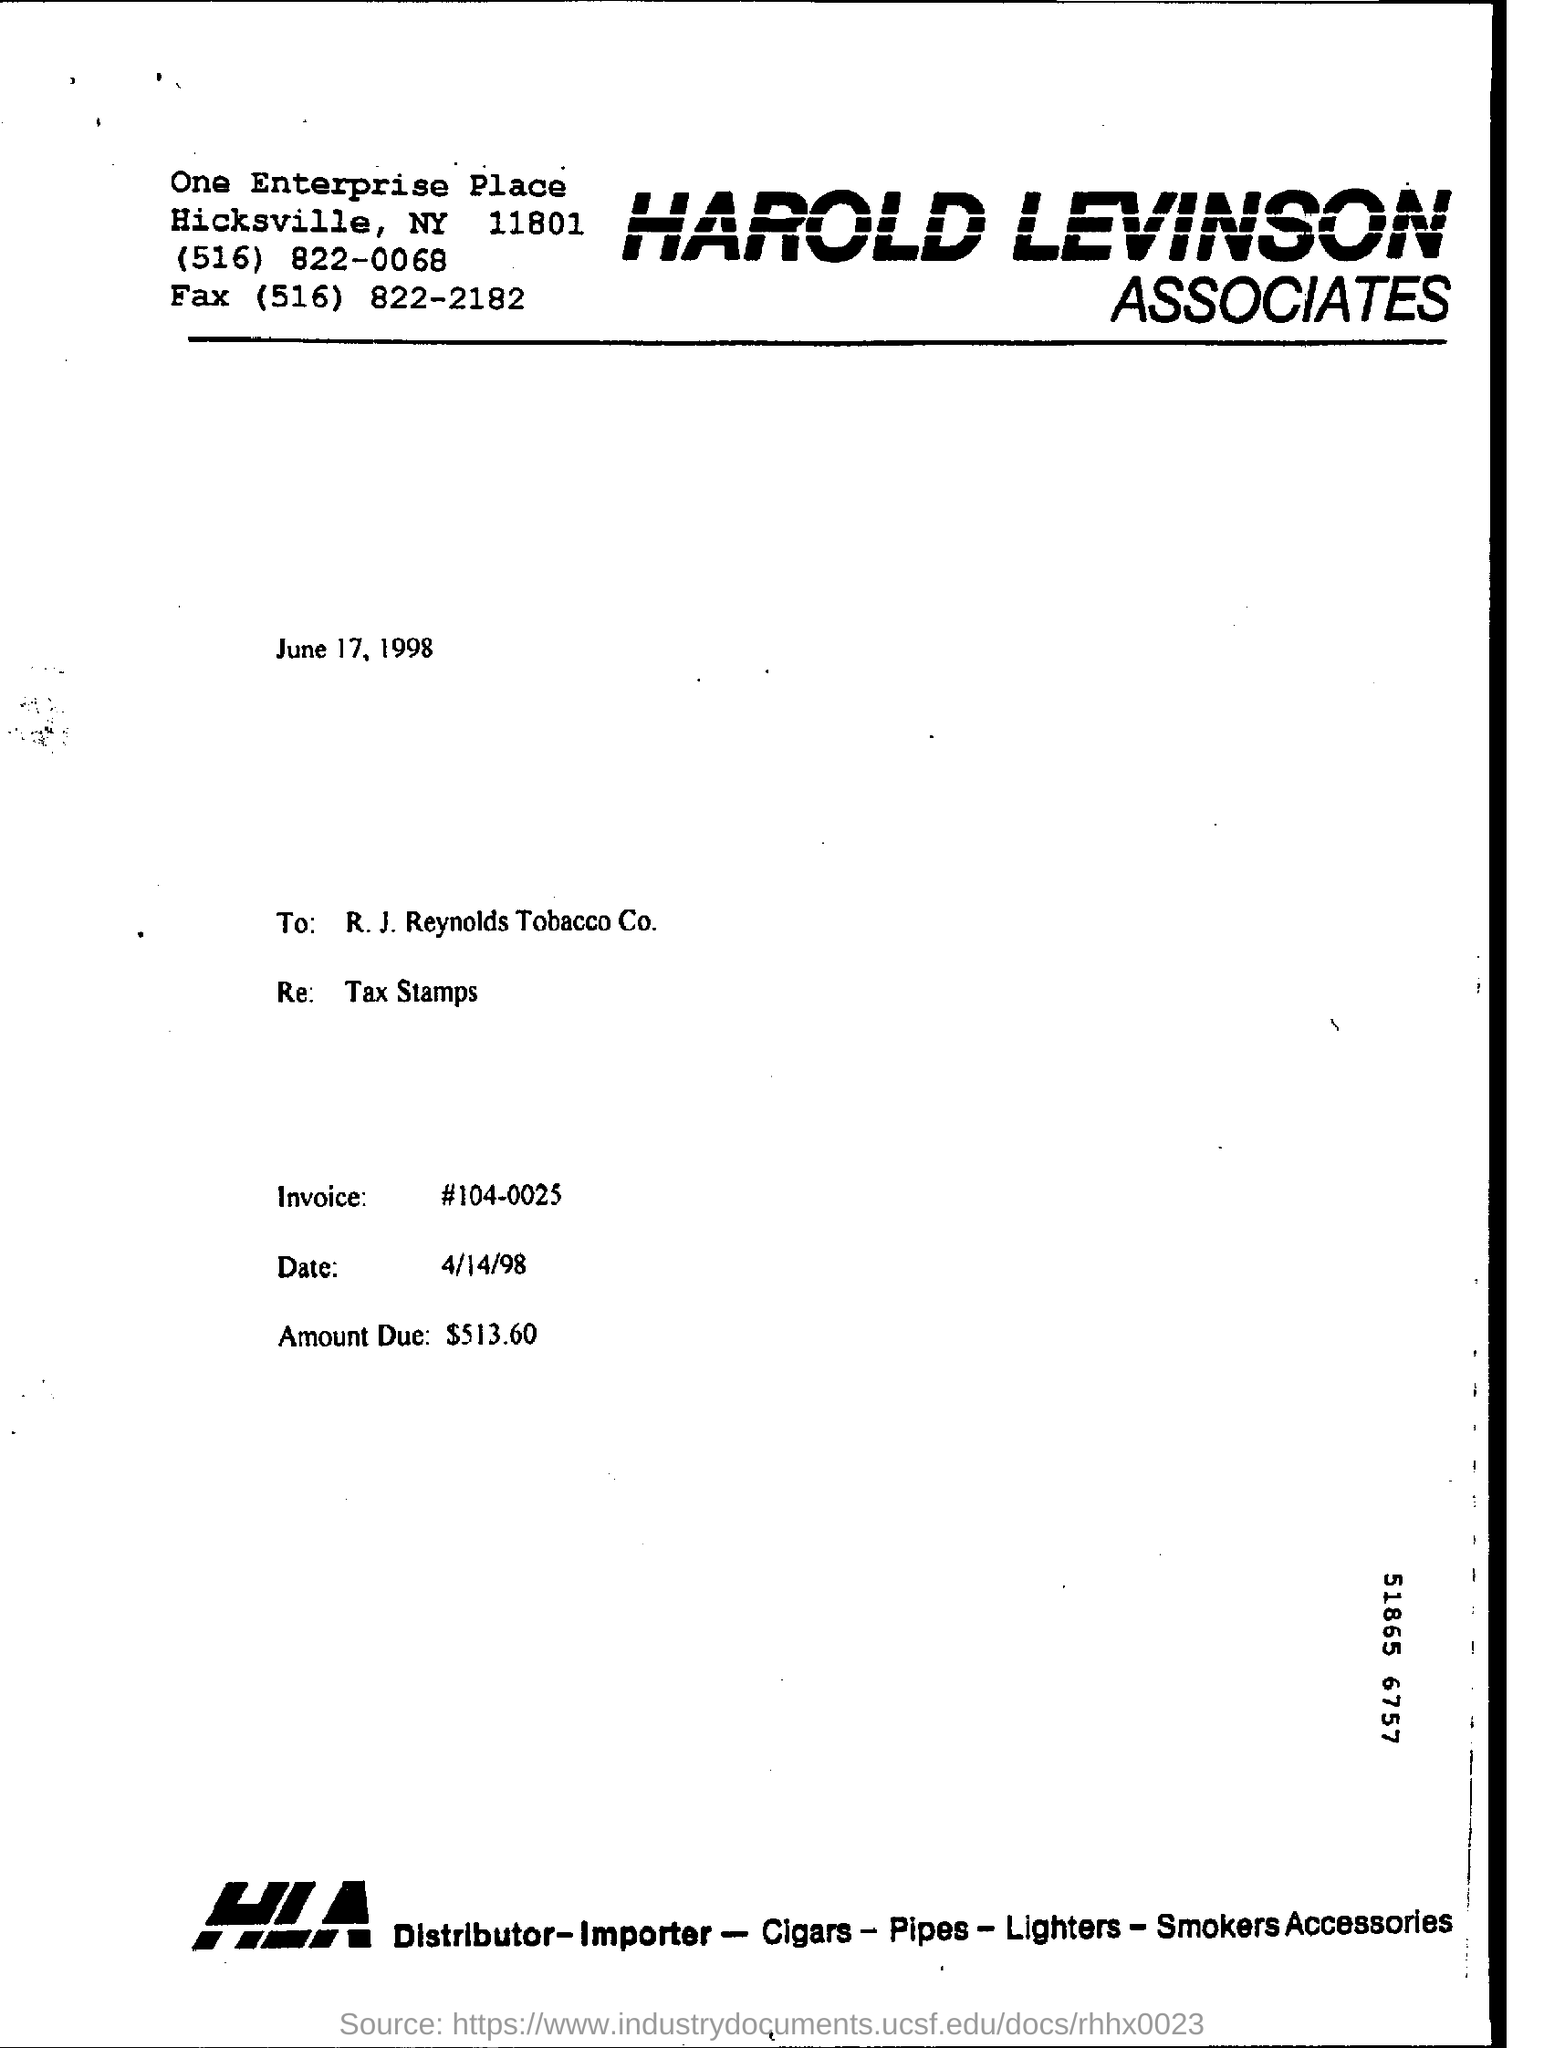What is the name of the company ?
Keep it short and to the point. Harold Levinson  Associates. How much  is the amount due ?
Give a very brief answer. 513.60. What is the invoice number ?
Provide a succinct answer. #104-0025. What is mentioned in the re:
Provide a succinct answer. Tax Stamps. What is the full form of hla ?
Provide a short and direct response. Harold Levinson Associates. 